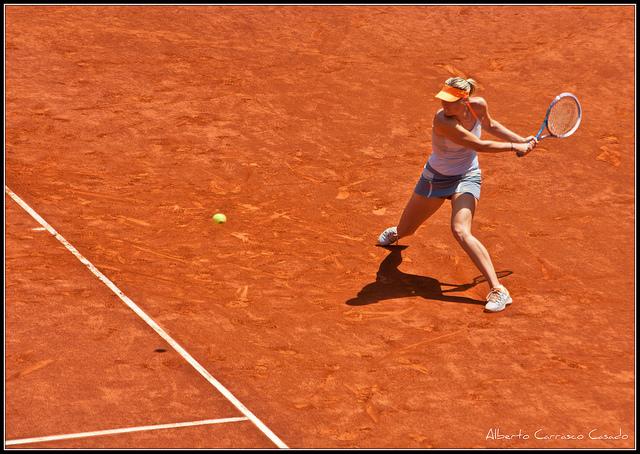Is the person wearing an armband?
Write a very short answer. No. What color is the female's hat?
Write a very short answer. Orange. What is the surface of the court made of?
Write a very short answer. Clay. What is the color of the visor?
Give a very brief answer. Orange. What color is this person's shorts?
Be succinct. Blue. What game is being played?
Be succinct. Tennis. Is this woman wearing a sun visor?
Write a very short answer. Yes. Did she just hit the tennis ball?
Answer briefly. No. 